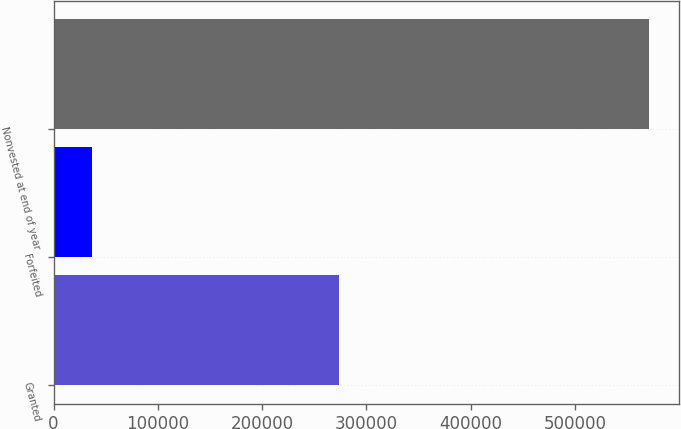Convert chart. <chart><loc_0><loc_0><loc_500><loc_500><bar_chart><fcel>Granted<fcel>Forfeited<fcel>Nonvested at end of year<nl><fcel>273497<fcel>36788<fcel>570814<nl></chart> 